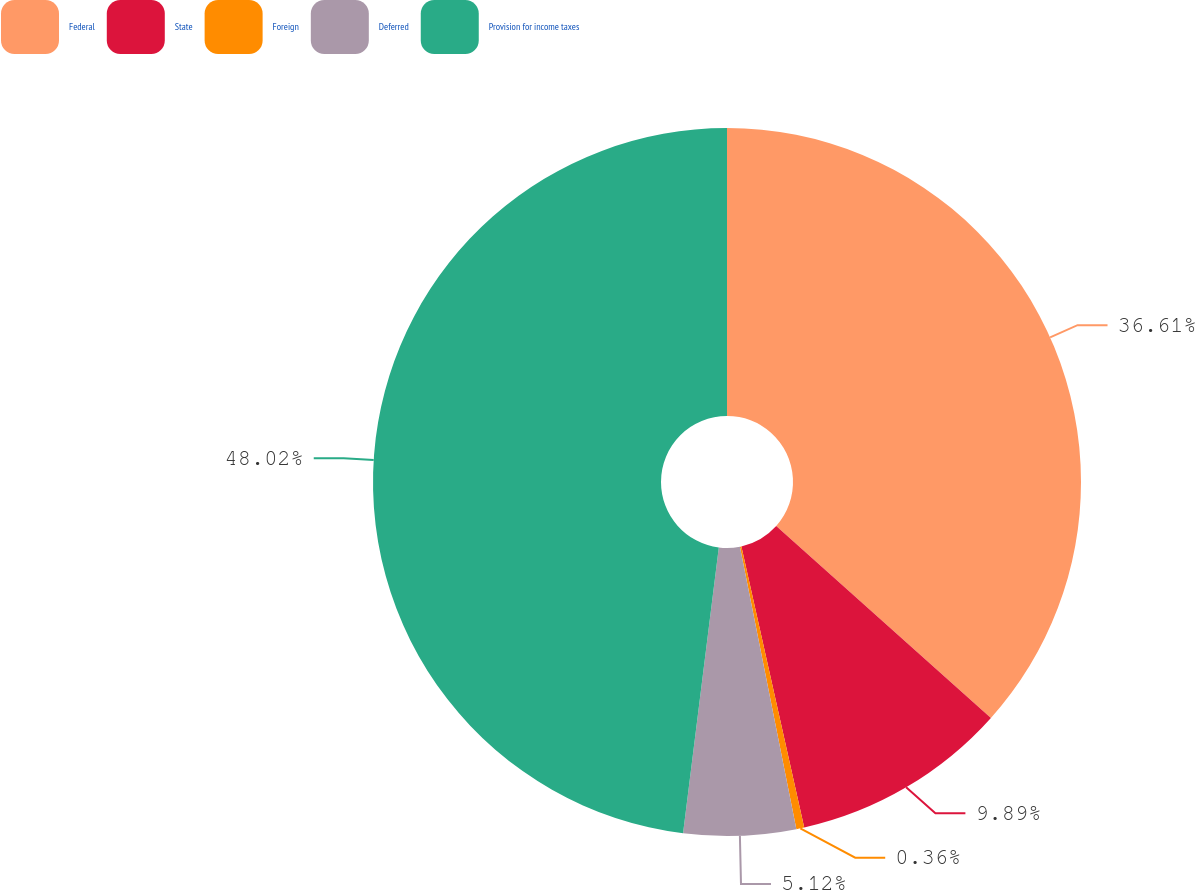Convert chart. <chart><loc_0><loc_0><loc_500><loc_500><pie_chart><fcel>Federal<fcel>State<fcel>Foreign<fcel>Deferred<fcel>Provision for income taxes<nl><fcel>36.61%<fcel>9.89%<fcel>0.36%<fcel>5.12%<fcel>48.02%<nl></chart> 